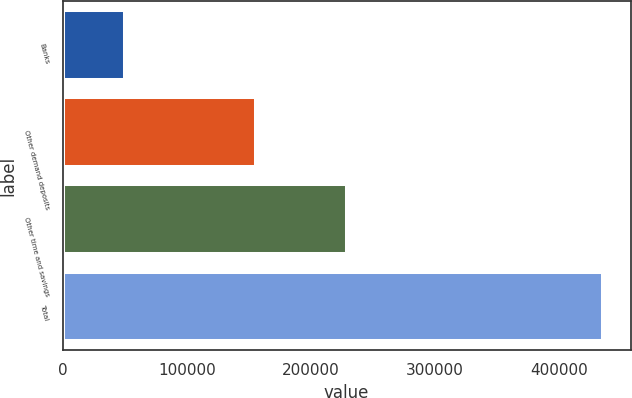Convert chart. <chart><loc_0><loc_0><loc_500><loc_500><bar_chart><fcel>Banks<fcel>Other demand deposits<fcel>Other time and savings<fcel>Total<nl><fcel>50478<fcel>156197<fcel>229376<fcel>436051<nl></chart> 